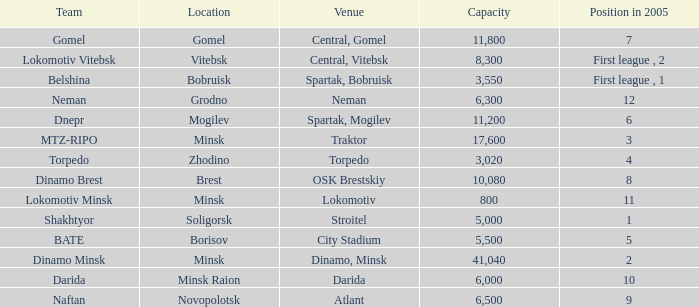Can you tell me the Capacity that has the Position in 2005 of 8? 10080.0. 